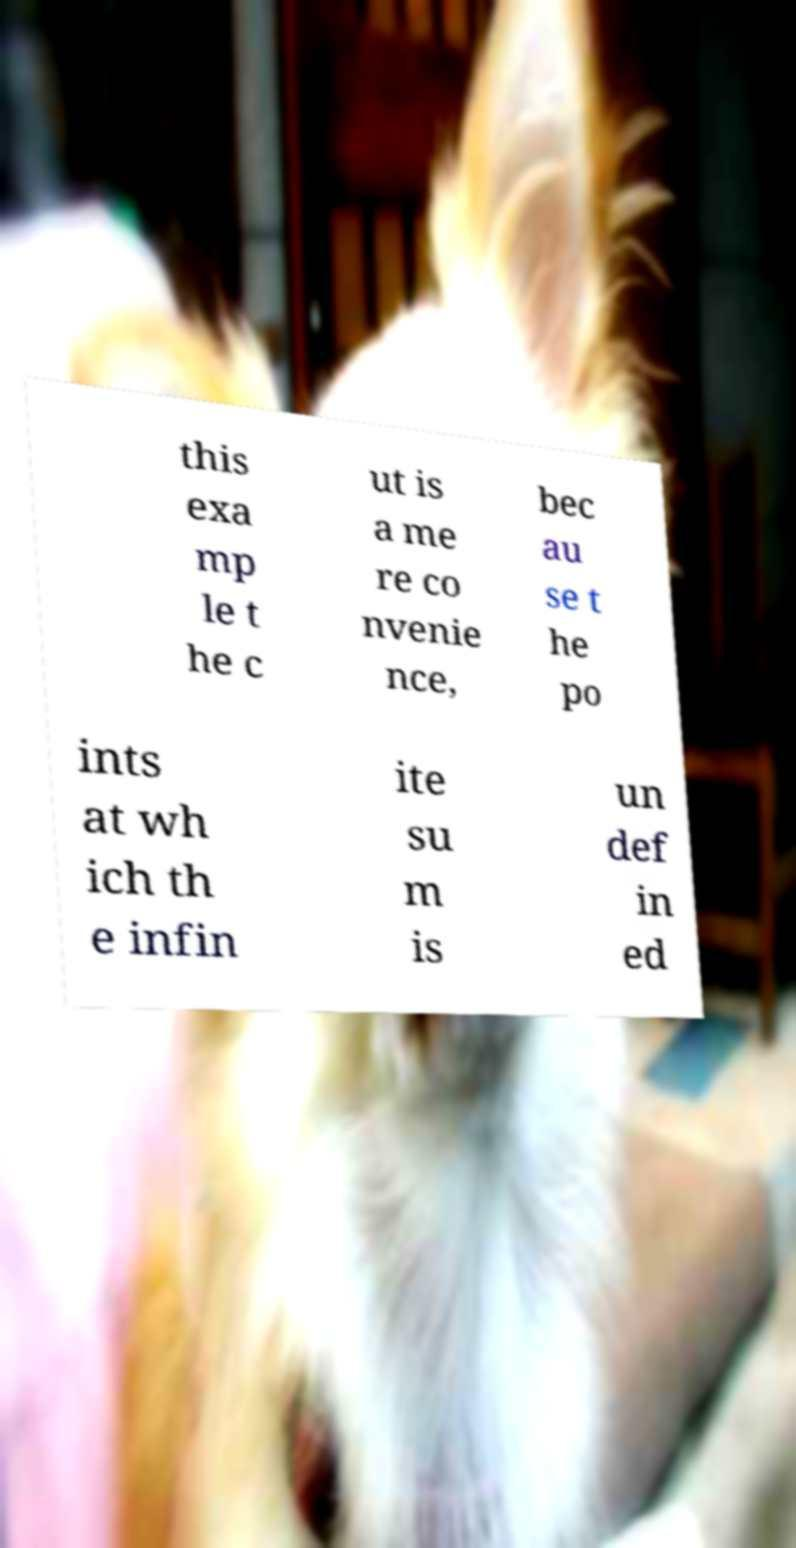For documentation purposes, I need the text within this image transcribed. Could you provide that? this exa mp le t he c ut is a me re co nvenie nce, bec au se t he po ints at wh ich th e infin ite su m is un def in ed 